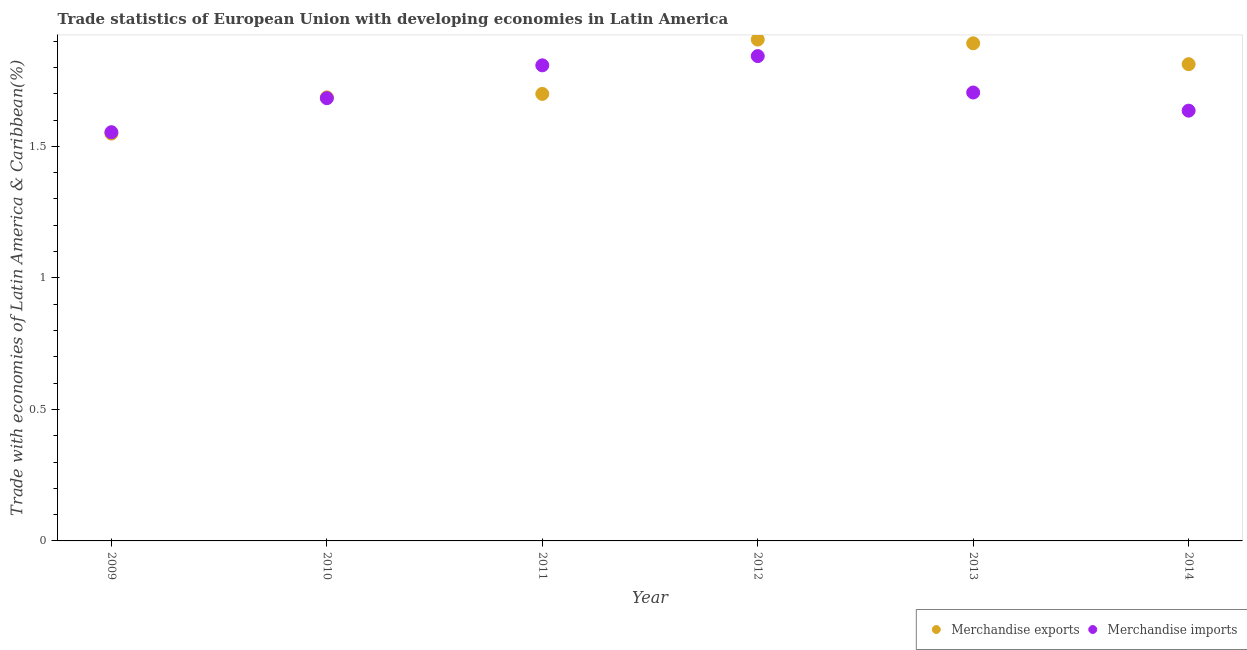Is the number of dotlines equal to the number of legend labels?
Provide a short and direct response. Yes. What is the merchandise imports in 2009?
Your answer should be very brief. 1.55. Across all years, what is the maximum merchandise imports?
Ensure brevity in your answer.  1.84. Across all years, what is the minimum merchandise exports?
Ensure brevity in your answer.  1.55. In which year was the merchandise exports minimum?
Offer a terse response. 2009. What is the total merchandise exports in the graph?
Your answer should be compact. 10.54. What is the difference between the merchandise exports in 2009 and that in 2013?
Ensure brevity in your answer.  -0.34. What is the difference between the merchandise imports in 2012 and the merchandise exports in 2009?
Ensure brevity in your answer.  0.29. What is the average merchandise exports per year?
Offer a terse response. 1.76. In the year 2014, what is the difference between the merchandise imports and merchandise exports?
Provide a short and direct response. -0.18. What is the ratio of the merchandise exports in 2012 to that in 2013?
Provide a succinct answer. 1.01. What is the difference between the highest and the second highest merchandise exports?
Your response must be concise. 0.01. What is the difference between the highest and the lowest merchandise exports?
Offer a very short reply. 0.36. In how many years, is the merchandise exports greater than the average merchandise exports taken over all years?
Provide a succinct answer. 3. Does the merchandise imports monotonically increase over the years?
Provide a short and direct response. No. Is the merchandise exports strictly less than the merchandise imports over the years?
Ensure brevity in your answer.  No. How many dotlines are there?
Provide a succinct answer. 2. How many years are there in the graph?
Provide a succinct answer. 6. Where does the legend appear in the graph?
Ensure brevity in your answer.  Bottom right. How are the legend labels stacked?
Provide a short and direct response. Horizontal. What is the title of the graph?
Your answer should be compact. Trade statistics of European Union with developing economies in Latin America. What is the label or title of the X-axis?
Your answer should be very brief. Year. What is the label or title of the Y-axis?
Your response must be concise. Trade with economies of Latin America & Caribbean(%). What is the Trade with economies of Latin America & Caribbean(%) in Merchandise exports in 2009?
Offer a terse response. 1.55. What is the Trade with economies of Latin America & Caribbean(%) in Merchandise imports in 2009?
Keep it short and to the point. 1.55. What is the Trade with economies of Latin America & Caribbean(%) of Merchandise exports in 2010?
Your response must be concise. 1.69. What is the Trade with economies of Latin America & Caribbean(%) in Merchandise imports in 2010?
Your response must be concise. 1.68. What is the Trade with economies of Latin America & Caribbean(%) of Merchandise exports in 2011?
Make the answer very short. 1.7. What is the Trade with economies of Latin America & Caribbean(%) in Merchandise imports in 2011?
Offer a very short reply. 1.81. What is the Trade with economies of Latin America & Caribbean(%) of Merchandise exports in 2012?
Offer a very short reply. 1.91. What is the Trade with economies of Latin America & Caribbean(%) of Merchandise imports in 2012?
Offer a very short reply. 1.84. What is the Trade with economies of Latin America & Caribbean(%) of Merchandise exports in 2013?
Your response must be concise. 1.89. What is the Trade with economies of Latin America & Caribbean(%) in Merchandise imports in 2013?
Provide a succinct answer. 1.7. What is the Trade with economies of Latin America & Caribbean(%) in Merchandise exports in 2014?
Ensure brevity in your answer.  1.81. What is the Trade with economies of Latin America & Caribbean(%) in Merchandise imports in 2014?
Make the answer very short. 1.64. Across all years, what is the maximum Trade with economies of Latin America & Caribbean(%) in Merchandise exports?
Ensure brevity in your answer.  1.91. Across all years, what is the maximum Trade with economies of Latin America & Caribbean(%) in Merchandise imports?
Provide a succinct answer. 1.84. Across all years, what is the minimum Trade with economies of Latin America & Caribbean(%) of Merchandise exports?
Make the answer very short. 1.55. Across all years, what is the minimum Trade with economies of Latin America & Caribbean(%) in Merchandise imports?
Offer a terse response. 1.55. What is the total Trade with economies of Latin America & Caribbean(%) in Merchandise exports in the graph?
Give a very brief answer. 10.54. What is the total Trade with economies of Latin America & Caribbean(%) in Merchandise imports in the graph?
Keep it short and to the point. 10.23. What is the difference between the Trade with economies of Latin America & Caribbean(%) of Merchandise exports in 2009 and that in 2010?
Make the answer very short. -0.14. What is the difference between the Trade with economies of Latin America & Caribbean(%) of Merchandise imports in 2009 and that in 2010?
Give a very brief answer. -0.13. What is the difference between the Trade with economies of Latin America & Caribbean(%) in Merchandise exports in 2009 and that in 2011?
Ensure brevity in your answer.  -0.15. What is the difference between the Trade with economies of Latin America & Caribbean(%) in Merchandise imports in 2009 and that in 2011?
Provide a succinct answer. -0.25. What is the difference between the Trade with economies of Latin America & Caribbean(%) of Merchandise exports in 2009 and that in 2012?
Ensure brevity in your answer.  -0.36. What is the difference between the Trade with economies of Latin America & Caribbean(%) in Merchandise imports in 2009 and that in 2012?
Provide a short and direct response. -0.29. What is the difference between the Trade with economies of Latin America & Caribbean(%) in Merchandise exports in 2009 and that in 2013?
Make the answer very short. -0.34. What is the difference between the Trade with economies of Latin America & Caribbean(%) of Merchandise imports in 2009 and that in 2013?
Your response must be concise. -0.15. What is the difference between the Trade with economies of Latin America & Caribbean(%) of Merchandise exports in 2009 and that in 2014?
Give a very brief answer. -0.26. What is the difference between the Trade with economies of Latin America & Caribbean(%) of Merchandise imports in 2009 and that in 2014?
Make the answer very short. -0.08. What is the difference between the Trade with economies of Latin America & Caribbean(%) of Merchandise exports in 2010 and that in 2011?
Your answer should be very brief. -0.01. What is the difference between the Trade with economies of Latin America & Caribbean(%) in Merchandise imports in 2010 and that in 2011?
Make the answer very short. -0.12. What is the difference between the Trade with economies of Latin America & Caribbean(%) of Merchandise exports in 2010 and that in 2012?
Your answer should be very brief. -0.22. What is the difference between the Trade with economies of Latin America & Caribbean(%) in Merchandise imports in 2010 and that in 2012?
Offer a terse response. -0.16. What is the difference between the Trade with economies of Latin America & Caribbean(%) of Merchandise exports in 2010 and that in 2013?
Give a very brief answer. -0.21. What is the difference between the Trade with economies of Latin America & Caribbean(%) in Merchandise imports in 2010 and that in 2013?
Make the answer very short. -0.02. What is the difference between the Trade with economies of Latin America & Caribbean(%) of Merchandise exports in 2010 and that in 2014?
Ensure brevity in your answer.  -0.13. What is the difference between the Trade with economies of Latin America & Caribbean(%) in Merchandise imports in 2010 and that in 2014?
Give a very brief answer. 0.05. What is the difference between the Trade with economies of Latin America & Caribbean(%) in Merchandise exports in 2011 and that in 2012?
Keep it short and to the point. -0.21. What is the difference between the Trade with economies of Latin America & Caribbean(%) of Merchandise imports in 2011 and that in 2012?
Give a very brief answer. -0.04. What is the difference between the Trade with economies of Latin America & Caribbean(%) in Merchandise exports in 2011 and that in 2013?
Provide a short and direct response. -0.19. What is the difference between the Trade with economies of Latin America & Caribbean(%) of Merchandise imports in 2011 and that in 2013?
Give a very brief answer. 0.1. What is the difference between the Trade with economies of Latin America & Caribbean(%) of Merchandise exports in 2011 and that in 2014?
Your answer should be compact. -0.11. What is the difference between the Trade with economies of Latin America & Caribbean(%) in Merchandise imports in 2011 and that in 2014?
Give a very brief answer. 0.17. What is the difference between the Trade with economies of Latin America & Caribbean(%) in Merchandise exports in 2012 and that in 2013?
Provide a short and direct response. 0.01. What is the difference between the Trade with economies of Latin America & Caribbean(%) in Merchandise imports in 2012 and that in 2013?
Give a very brief answer. 0.14. What is the difference between the Trade with economies of Latin America & Caribbean(%) in Merchandise exports in 2012 and that in 2014?
Your response must be concise. 0.09. What is the difference between the Trade with economies of Latin America & Caribbean(%) of Merchandise imports in 2012 and that in 2014?
Keep it short and to the point. 0.21. What is the difference between the Trade with economies of Latin America & Caribbean(%) of Merchandise exports in 2013 and that in 2014?
Your answer should be compact. 0.08. What is the difference between the Trade with economies of Latin America & Caribbean(%) of Merchandise imports in 2013 and that in 2014?
Your answer should be compact. 0.07. What is the difference between the Trade with economies of Latin America & Caribbean(%) in Merchandise exports in 2009 and the Trade with economies of Latin America & Caribbean(%) in Merchandise imports in 2010?
Your answer should be compact. -0.13. What is the difference between the Trade with economies of Latin America & Caribbean(%) in Merchandise exports in 2009 and the Trade with economies of Latin America & Caribbean(%) in Merchandise imports in 2011?
Keep it short and to the point. -0.26. What is the difference between the Trade with economies of Latin America & Caribbean(%) of Merchandise exports in 2009 and the Trade with economies of Latin America & Caribbean(%) of Merchandise imports in 2012?
Keep it short and to the point. -0.29. What is the difference between the Trade with economies of Latin America & Caribbean(%) of Merchandise exports in 2009 and the Trade with economies of Latin America & Caribbean(%) of Merchandise imports in 2013?
Offer a terse response. -0.16. What is the difference between the Trade with economies of Latin America & Caribbean(%) in Merchandise exports in 2009 and the Trade with economies of Latin America & Caribbean(%) in Merchandise imports in 2014?
Your answer should be very brief. -0.09. What is the difference between the Trade with economies of Latin America & Caribbean(%) in Merchandise exports in 2010 and the Trade with economies of Latin America & Caribbean(%) in Merchandise imports in 2011?
Keep it short and to the point. -0.12. What is the difference between the Trade with economies of Latin America & Caribbean(%) of Merchandise exports in 2010 and the Trade with economies of Latin America & Caribbean(%) of Merchandise imports in 2012?
Keep it short and to the point. -0.16. What is the difference between the Trade with economies of Latin America & Caribbean(%) in Merchandise exports in 2010 and the Trade with economies of Latin America & Caribbean(%) in Merchandise imports in 2013?
Offer a terse response. -0.02. What is the difference between the Trade with economies of Latin America & Caribbean(%) of Merchandise exports in 2010 and the Trade with economies of Latin America & Caribbean(%) of Merchandise imports in 2014?
Make the answer very short. 0.05. What is the difference between the Trade with economies of Latin America & Caribbean(%) in Merchandise exports in 2011 and the Trade with economies of Latin America & Caribbean(%) in Merchandise imports in 2012?
Provide a short and direct response. -0.14. What is the difference between the Trade with economies of Latin America & Caribbean(%) of Merchandise exports in 2011 and the Trade with economies of Latin America & Caribbean(%) of Merchandise imports in 2013?
Your response must be concise. -0.01. What is the difference between the Trade with economies of Latin America & Caribbean(%) in Merchandise exports in 2011 and the Trade with economies of Latin America & Caribbean(%) in Merchandise imports in 2014?
Give a very brief answer. 0.06. What is the difference between the Trade with economies of Latin America & Caribbean(%) in Merchandise exports in 2012 and the Trade with economies of Latin America & Caribbean(%) in Merchandise imports in 2013?
Ensure brevity in your answer.  0.2. What is the difference between the Trade with economies of Latin America & Caribbean(%) of Merchandise exports in 2012 and the Trade with economies of Latin America & Caribbean(%) of Merchandise imports in 2014?
Make the answer very short. 0.27. What is the difference between the Trade with economies of Latin America & Caribbean(%) in Merchandise exports in 2013 and the Trade with economies of Latin America & Caribbean(%) in Merchandise imports in 2014?
Ensure brevity in your answer.  0.26. What is the average Trade with economies of Latin America & Caribbean(%) in Merchandise exports per year?
Your response must be concise. 1.76. What is the average Trade with economies of Latin America & Caribbean(%) in Merchandise imports per year?
Your answer should be compact. 1.7. In the year 2009, what is the difference between the Trade with economies of Latin America & Caribbean(%) in Merchandise exports and Trade with economies of Latin America & Caribbean(%) in Merchandise imports?
Make the answer very short. -0.01. In the year 2010, what is the difference between the Trade with economies of Latin America & Caribbean(%) in Merchandise exports and Trade with economies of Latin America & Caribbean(%) in Merchandise imports?
Give a very brief answer. 0. In the year 2011, what is the difference between the Trade with economies of Latin America & Caribbean(%) of Merchandise exports and Trade with economies of Latin America & Caribbean(%) of Merchandise imports?
Offer a very short reply. -0.11. In the year 2012, what is the difference between the Trade with economies of Latin America & Caribbean(%) of Merchandise exports and Trade with economies of Latin America & Caribbean(%) of Merchandise imports?
Your answer should be compact. 0.06. In the year 2013, what is the difference between the Trade with economies of Latin America & Caribbean(%) in Merchandise exports and Trade with economies of Latin America & Caribbean(%) in Merchandise imports?
Provide a succinct answer. 0.19. In the year 2014, what is the difference between the Trade with economies of Latin America & Caribbean(%) in Merchandise exports and Trade with economies of Latin America & Caribbean(%) in Merchandise imports?
Make the answer very short. 0.18. What is the ratio of the Trade with economies of Latin America & Caribbean(%) of Merchandise exports in 2009 to that in 2010?
Your answer should be very brief. 0.92. What is the ratio of the Trade with economies of Latin America & Caribbean(%) in Merchandise imports in 2009 to that in 2010?
Provide a succinct answer. 0.92. What is the ratio of the Trade with economies of Latin America & Caribbean(%) of Merchandise exports in 2009 to that in 2011?
Your response must be concise. 0.91. What is the ratio of the Trade with economies of Latin America & Caribbean(%) in Merchandise imports in 2009 to that in 2011?
Your response must be concise. 0.86. What is the ratio of the Trade with economies of Latin America & Caribbean(%) in Merchandise exports in 2009 to that in 2012?
Make the answer very short. 0.81. What is the ratio of the Trade with economies of Latin America & Caribbean(%) of Merchandise imports in 2009 to that in 2012?
Keep it short and to the point. 0.84. What is the ratio of the Trade with economies of Latin America & Caribbean(%) in Merchandise exports in 2009 to that in 2013?
Offer a terse response. 0.82. What is the ratio of the Trade with economies of Latin America & Caribbean(%) in Merchandise imports in 2009 to that in 2013?
Offer a very short reply. 0.91. What is the ratio of the Trade with economies of Latin America & Caribbean(%) of Merchandise exports in 2009 to that in 2014?
Provide a succinct answer. 0.85. What is the ratio of the Trade with economies of Latin America & Caribbean(%) of Merchandise exports in 2010 to that in 2011?
Your response must be concise. 0.99. What is the ratio of the Trade with economies of Latin America & Caribbean(%) of Merchandise imports in 2010 to that in 2011?
Keep it short and to the point. 0.93. What is the ratio of the Trade with economies of Latin America & Caribbean(%) in Merchandise exports in 2010 to that in 2012?
Offer a terse response. 0.88. What is the ratio of the Trade with economies of Latin America & Caribbean(%) of Merchandise imports in 2010 to that in 2012?
Offer a terse response. 0.91. What is the ratio of the Trade with economies of Latin America & Caribbean(%) in Merchandise exports in 2010 to that in 2013?
Provide a short and direct response. 0.89. What is the ratio of the Trade with economies of Latin America & Caribbean(%) in Merchandise imports in 2010 to that in 2013?
Your response must be concise. 0.99. What is the ratio of the Trade with economies of Latin America & Caribbean(%) in Merchandise exports in 2010 to that in 2014?
Provide a succinct answer. 0.93. What is the ratio of the Trade with economies of Latin America & Caribbean(%) in Merchandise imports in 2010 to that in 2014?
Your answer should be very brief. 1.03. What is the ratio of the Trade with economies of Latin America & Caribbean(%) of Merchandise exports in 2011 to that in 2012?
Ensure brevity in your answer.  0.89. What is the ratio of the Trade with economies of Latin America & Caribbean(%) in Merchandise exports in 2011 to that in 2013?
Provide a succinct answer. 0.9. What is the ratio of the Trade with economies of Latin America & Caribbean(%) of Merchandise imports in 2011 to that in 2013?
Offer a terse response. 1.06. What is the ratio of the Trade with economies of Latin America & Caribbean(%) of Merchandise exports in 2011 to that in 2014?
Keep it short and to the point. 0.94. What is the ratio of the Trade with economies of Latin America & Caribbean(%) of Merchandise imports in 2011 to that in 2014?
Provide a short and direct response. 1.11. What is the ratio of the Trade with economies of Latin America & Caribbean(%) of Merchandise exports in 2012 to that in 2013?
Your answer should be compact. 1.01. What is the ratio of the Trade with economies of Latin America & Caribbean(%) in Merchandise imports in 2012 to that in 2013?
Make the answer very short. 1.08. What is the ratio of the Trade with economies of Latin America & Caribbean(%) of Merchandise exports in 2012 to that in 2014?
Your answer should be compact. 1.05. What is the ratio of the Trade with economies of Latin America & Caribbean(%) of Merchandise imports in 2012 to that in 2014?
Provide a short and direct response. 1.13. What is the ratio of the Trade with economies of Latin America & Caribbean(%) in Merchandise exports in 2013 to that in 2014?
Keep it short and to the point. 1.04. What is the ratio of the Trade with economies of Latin America & Caribbean(%) of Merchandise imports in 2013 to that in 2014?
Ensure brevity in your answer.  1.04. What is the difference between the highest and the second highest Trade with economies of Latin America & Caribbean(%) in Merchandise exports?
Give a very brief answer. 0.01. What is the difference between the highest and the second highest Trade with economies of Latin America & Caribbean(%) in Merchandise imports?
Your answer should be compact. 0.04. What is the difference between the highest and the lowest Trade with economies of Latin America & Caribbean(%) in Merchandise exports?
Offer a terse response. 0.36. What is the difference between the highest and the lowest Trade with economies of Latin America & Caribbean(%) of Merchandise imports?
Offer a very short reply. 0.29. 